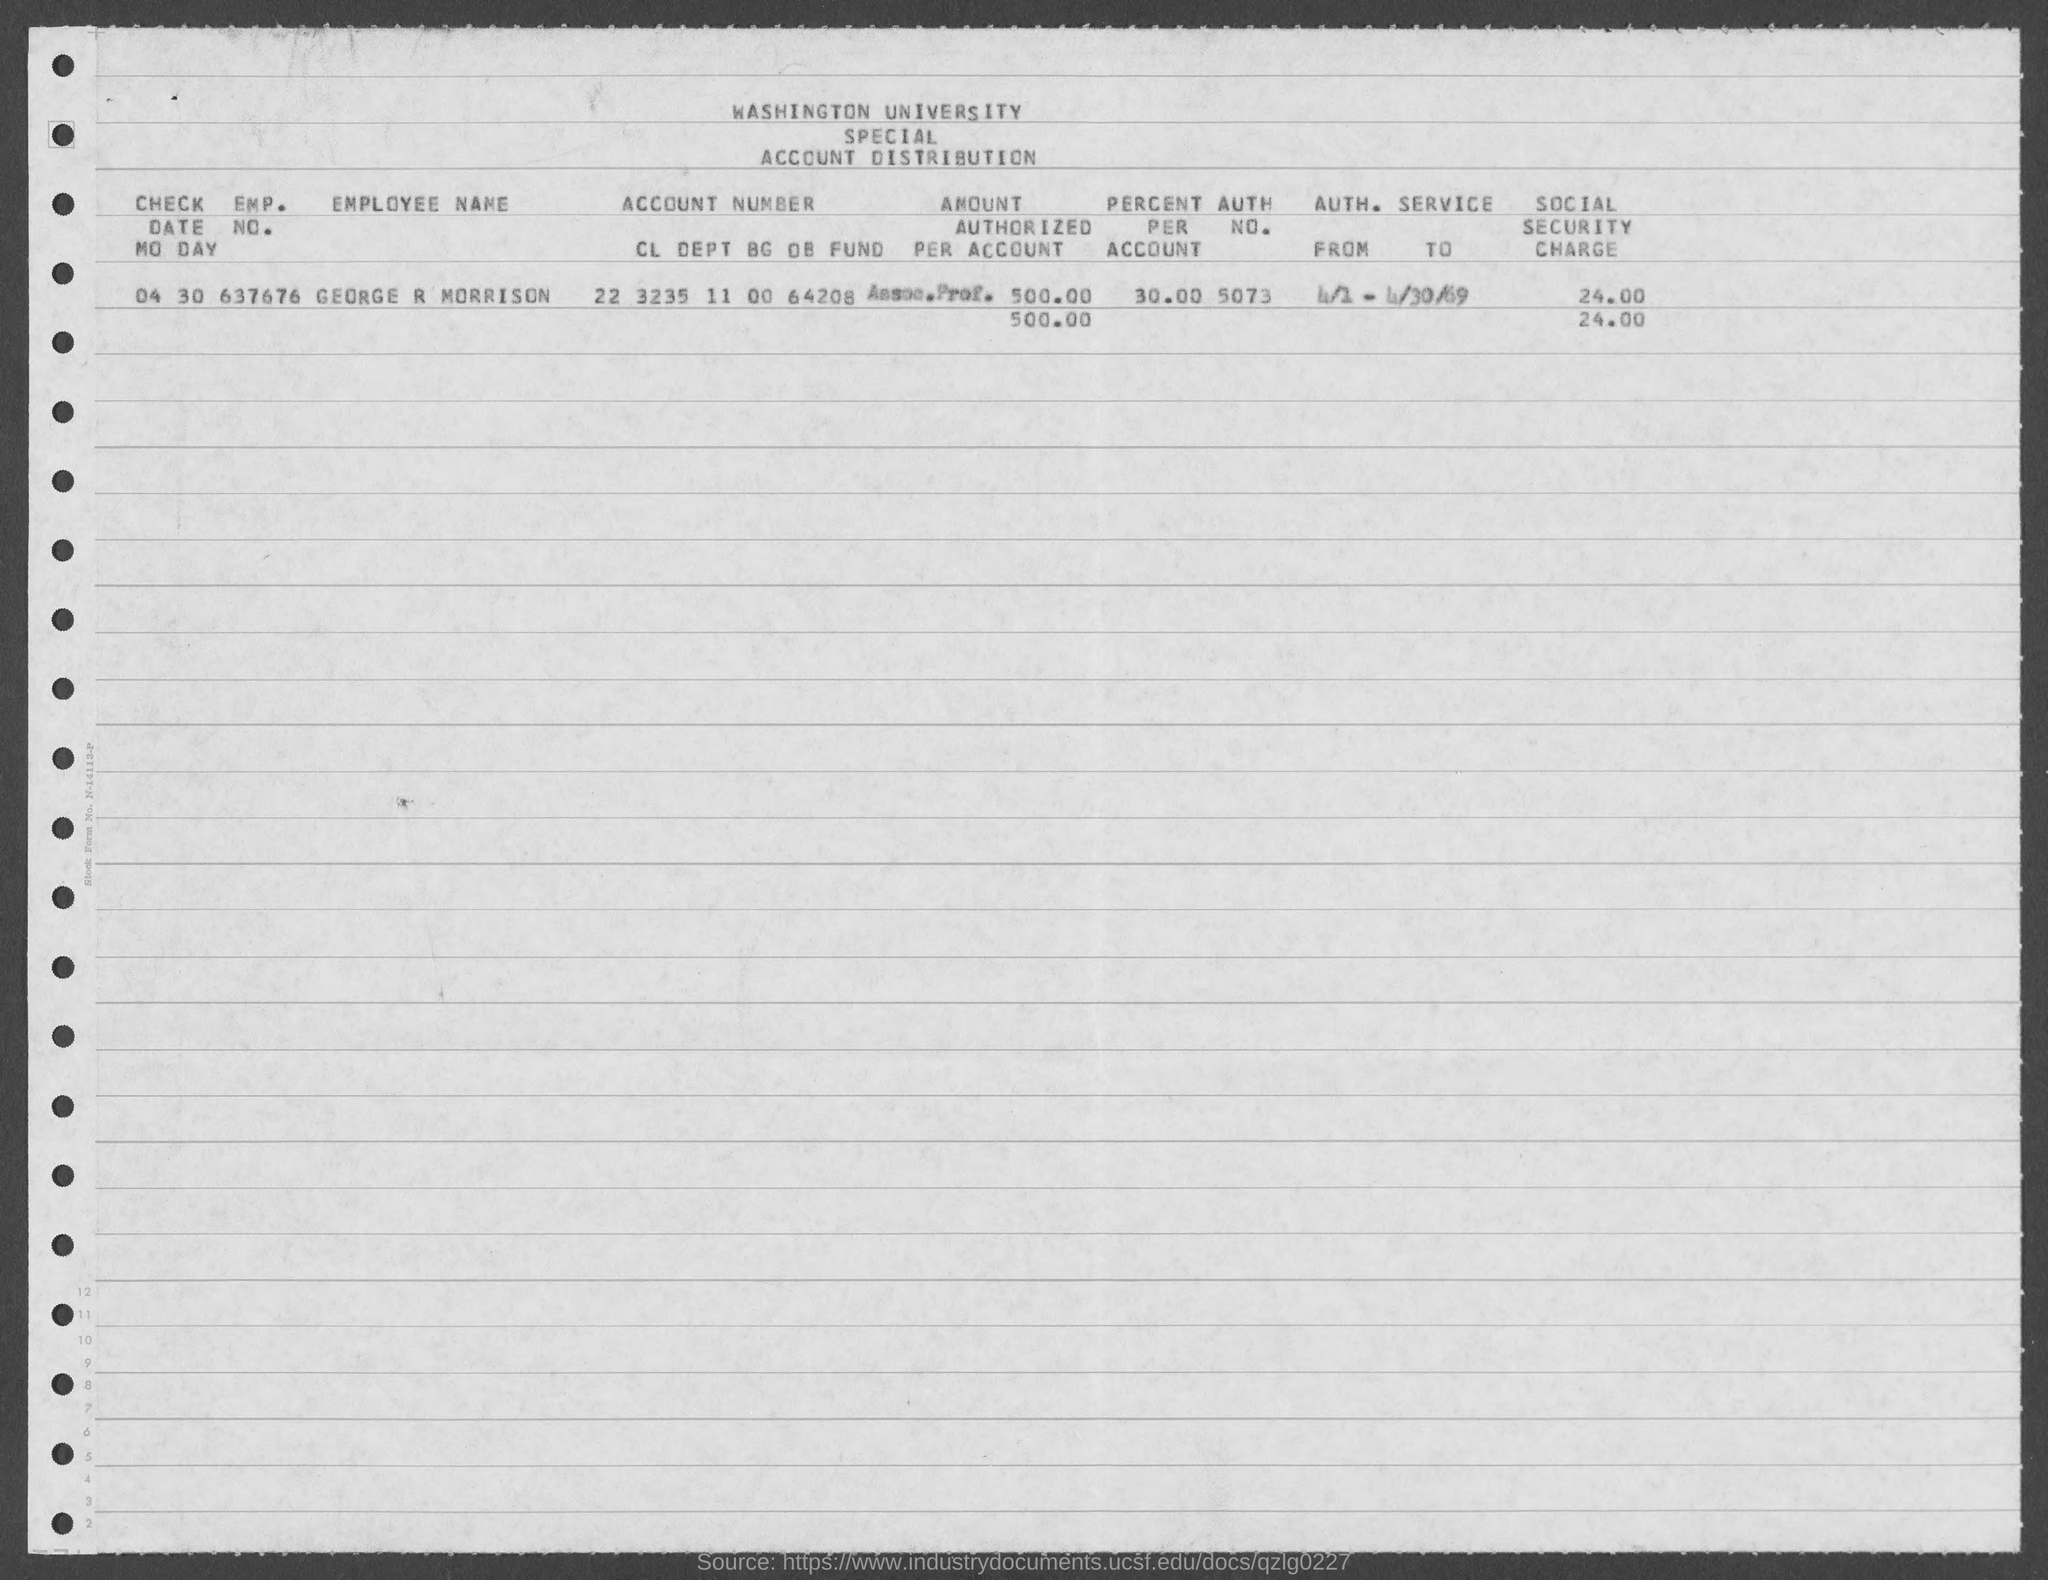Which university's account distirbution is given here?
Your answer should be very brief. Washington university. What is the EMP. NO. of GEORGE R MORRISON?
Provide a succinct answer. 637676. What is the amount authorized per account of GEORGE R MORRISON?
Provide a succinct answer. 500.00. What is the percent per account of GEORGE R MORRISON?
Your answer should be compact. 30.00. What is the AUTH. NO. of GEORGE R MORRISON given in the document?
Give a very brief answer. 5073. What is the social security charge for the Emp No. 637676?
Your response must be concise. 24.00. 